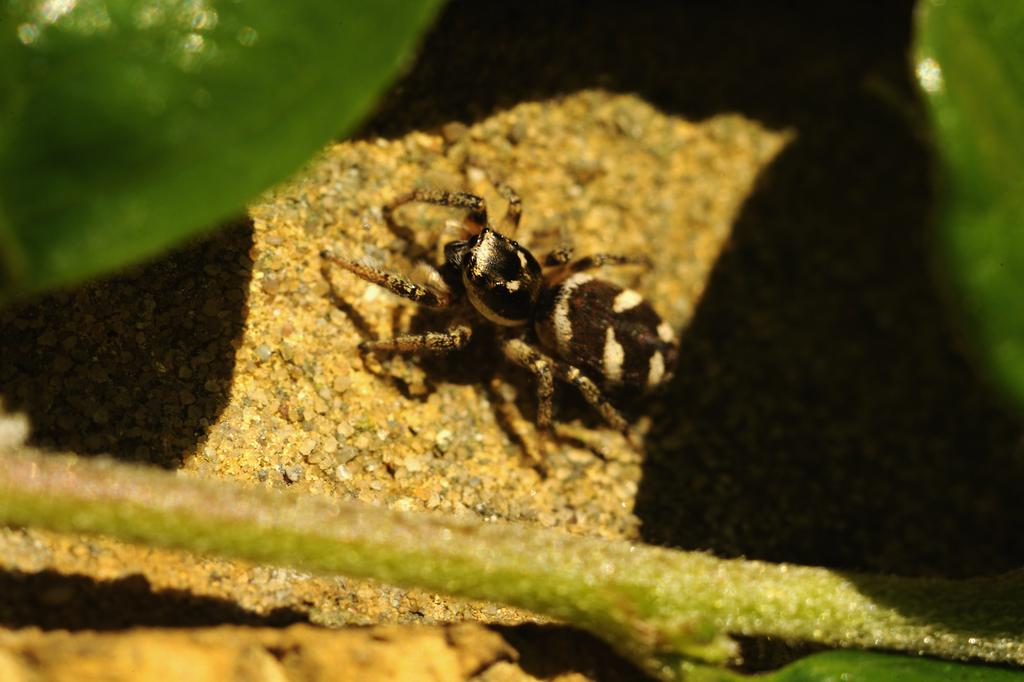What is located on the stone in the image? There is an insect on a stone in the image. What can be seen at the bottom of the image? There is a stem at the bottom of the image. What type of vegetation is visible at the top of the image? Leaves are visible at the top of the image. What type of houses can be seen in the background of the image? There are no houses present in the image; it features an insect on a stone with a stem and leaves. What process is being discussed in the image? There is no discussion or process depicted in the image; it is a still image of an insect on a stone with a stem and leaves. 